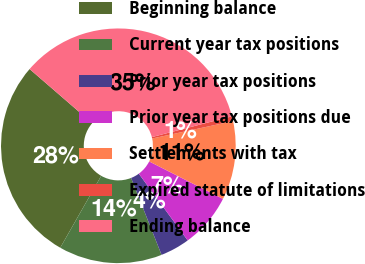Convert chart to OTSL. <chart><loc_0><loc_0><loc_500><loc_500><pie_chart><fcel>Beginning balance<fcel>Current year tax positions<fcel>Prior year tax positions<fcel>Prior year tax positions due<fcel>Settlements with tax<fcel>Expired statute of limitations<fcel>Ending balance<nl><fcel>28.1%<fcel>14.25%<fcel>4.06%<fcel>7.46%<fcel>10.85%<fcel>0.67%<fcel>34.61%<nl></chart> 